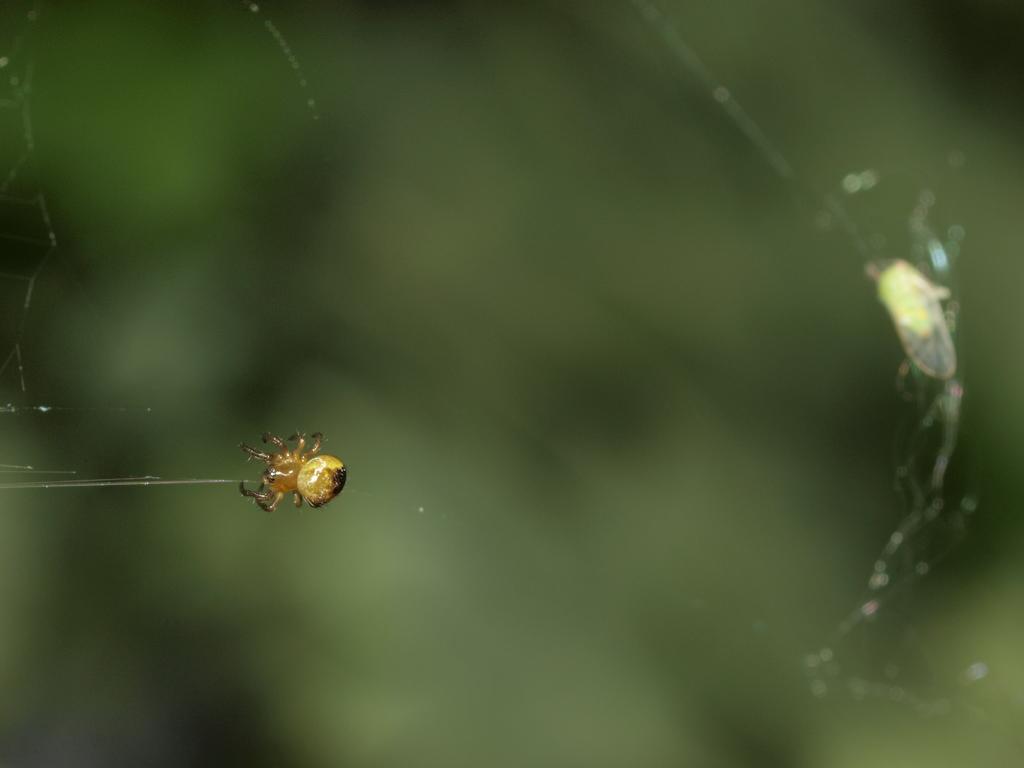Describe this image in one or two sentences. In the image there is a spider on the web and the background is blurry. 